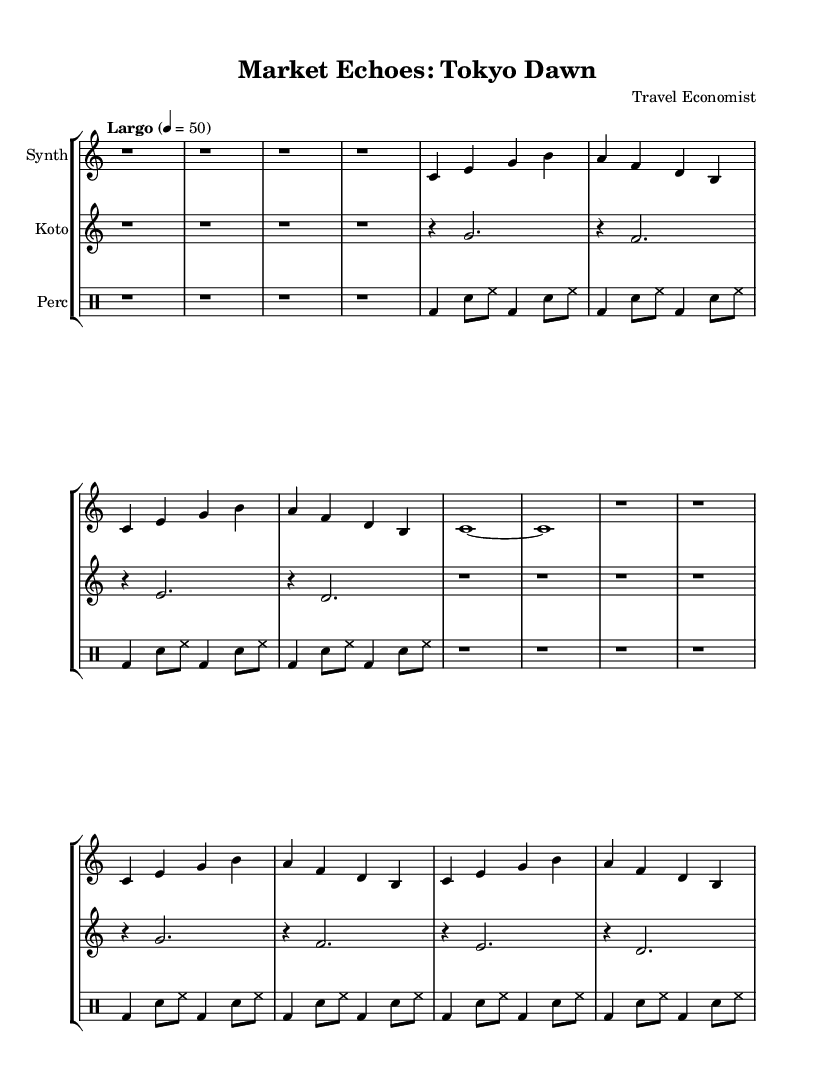What is the tempo marking of this piece? The tempo marking is provided in the global variable section as "Largo" with a speed of 50 beats per minute.
Answer: Largo, 50 What is the time signature of the music? The time signature is stated in the global settings as 4/4, which indicates four beats per measure.
Answer: 4/4 How many measures are in the synthesizer part? By counting the r1 indications, each with four beats, there are a total of 8 measures in the synthesizer part.
Answer: 8 What instruments are included in this composition? The score includes three parts: Synth, Koto, and Percussion, as identified in the StaffGroup section.
Answer: Synth, Koto, Percussion What type of music is this piece categorized as? The piece is described as "Experimental" based on the prompt context and reflects ambient characteristics by blending field recordings with economic data.
Answer: Experimental Which instrument plays a rhythmic pattern using bass drums and snare? The percussion instrument plays this rhythmic pattern, as shown in the drummode section with specific notations for bass drums (bd) and snares (sn).
Answer: Percussion In what location does the piece "Market Echoes: Tokyo Dawn" suggest it is inspired by? The title suggests that the inspiration comes from Tokyo, as indicated directly in the title of the score.
Answer: Tokyo 